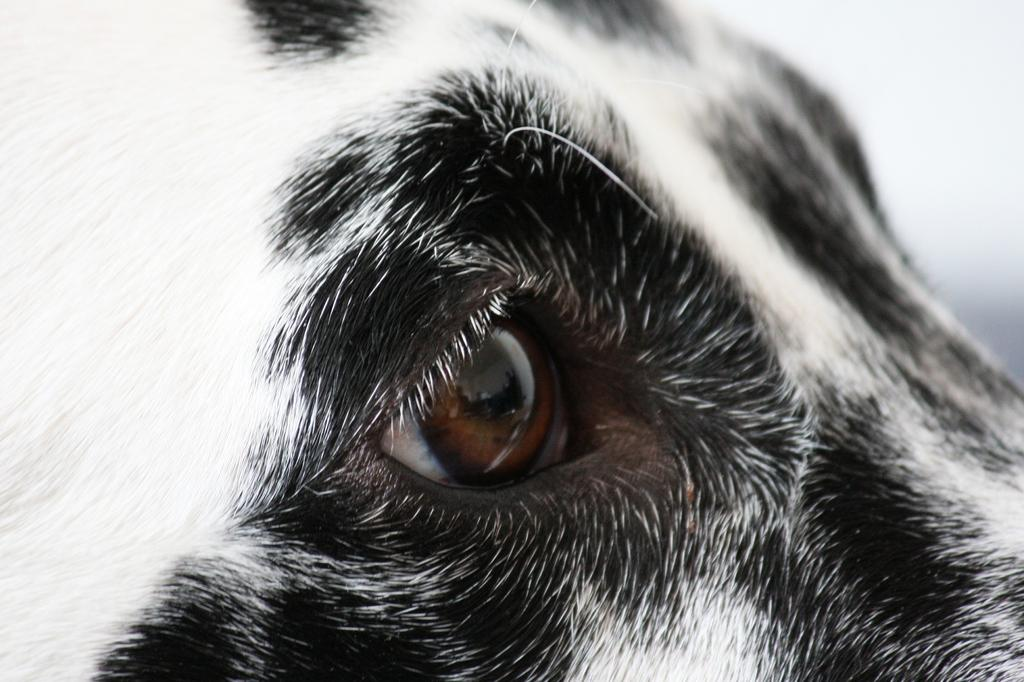What type of animal is in the foreground of the image? The animal in the foreground of the image is not specified, but its eye is visible. What color is the animal in the image? The animal is black and white in color. What is the color of the background in the image? The background of the image is white. Can you see the animal smiling in the image? There is no indication of the animal's facial expression, such as a smile, in the image. Is there a letter addressed to the animal in the image? There is no letter present in the image. 